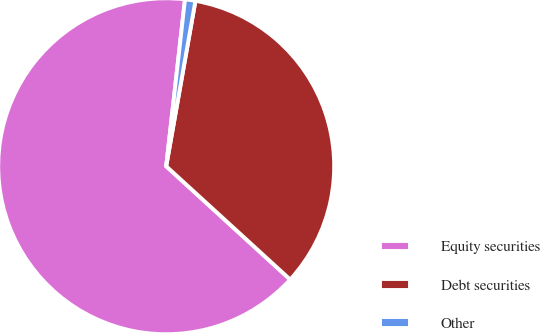<chart> <loc_0><loc_0><loc_500><loc_500><pie_chart><fcel>Equity securities<fcel>Debt securities<fcel>Other<nl><fcel>65.0%<fcel>34.0%<fcel>1.0%<nl></chart> 